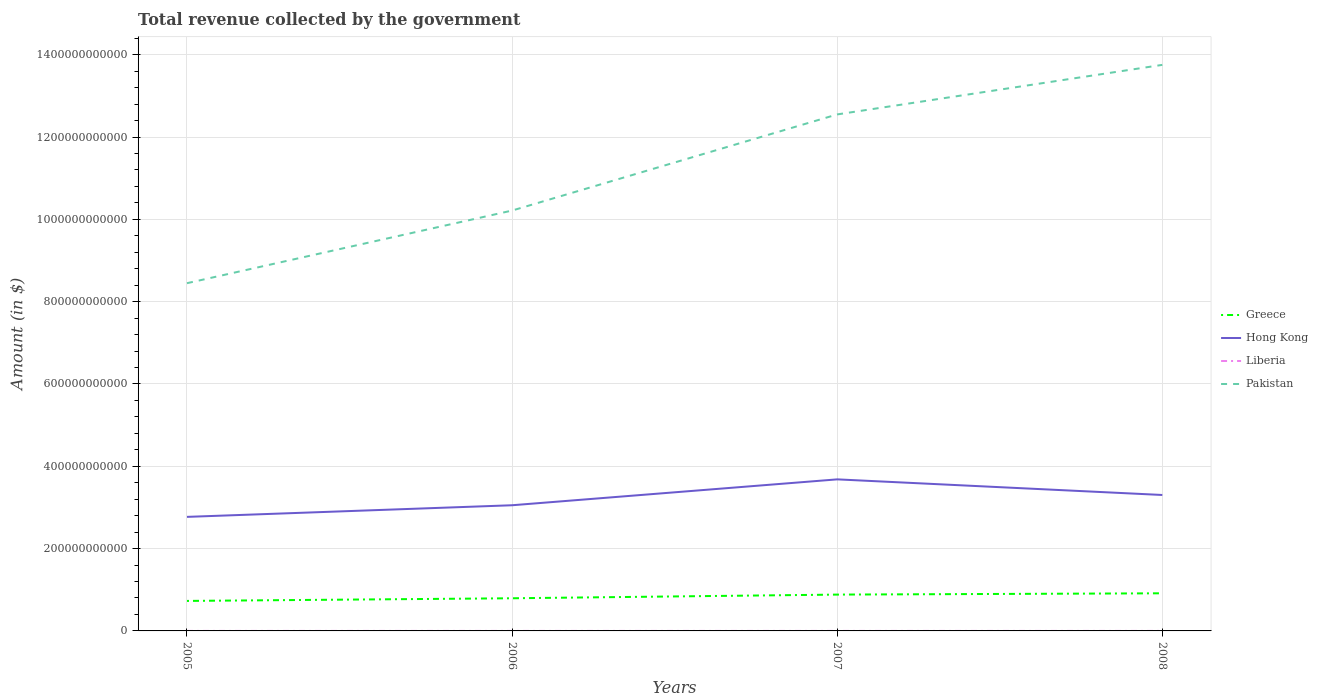Does the line corresponding to Pakistan intersect with the line corresponding to Hong Kong?
Your answer should be very brief. No. Is the number of lines equal to the number of legend labels?
Your answer should be very brief. Yes. Across all years, what is the maximum total revenue collected by the government in Hong Kong?
Your answer should be compact. 2.77e+11. In which year was the total revenue collected by the government in Pakistan maximum?
Keep it short and to the point. 2005. What is the total total revenue collected by the government in Greece in the graph?
Give a very brief answer. -6.44e+09. What is the difference between the highest and the second highest total revenue collected by the government in Pakistan?
Make the answer very short. 5.30e+11. What is the difference between two consecutive major ticks on the Y-axis?
Make the answer very short. 2.00e+11. Are the values on the major ticks of Y-axis written in scientific E-notation?
Provide a succinct answer. No. Where does the legend appear in the graph?
Keep it short and to the point. Center right. How are the legend labels stacked?
Provide a succinct answer. Vertical. What is the title of the graph?
Your response must be concise. Total revenue collected by the government. What is the label or title of the X-axis?
Keep it short and to the point. Years. What is the label or title of the Y-axis?
Your answer should be compact. Amount (in $). What is the Amount (in $) of Greece in 2005?
Provide a short and direct response. 7.29e+1. What is the Amount (in $) in Hong Kong in 2005?
Ensure brevity in your answer.  2.77e+11. What is the Amount (in $) in Liberia in 2005?
Provide a succinct answer. 1.39e+06. What is the Amount (in $) in Pakistan in 2005?
Make the answer very short. 8.45e+11. What is the Amount (in $) in Greece in 2006?
Make the answer very short. 7.93e+1. What is the Amount (in $) in Hong Kong in 2006?
Your response must be concise. 3.05e+11. What is the Amount (in $) of Liberia in 2006?
Keep it short and to the point. 1.46e+06. What is the Amount (in $) in Pakistan in 2006?
Give a very brief answer. 1.02e+12. What is the Amount (in $) in Greece in 2007?
Offer a terse response. 8.83e+1. What is the Amount (in $) in Hong Kong in 2007?
Keep it short and to the point. 3.68e+11. What is the Amount (in $) in Liberia in 2007?
Keep it short and to the point. 2.40e+06. What is the Amount (in $) of Pakistan in 2007?
Your answer should be compact. 1.25e+12. What is the Amount (in $) of Greece in 2008?
Your answer should be very brief. 9.14e+1. What is the Amount (in $) of Hong Kong in 2008?
Keep it short and to the point. 3.30e+11. What is the Amount (in $) in Liberia in 2008?
Provide a succinct answer. 3.18e+06. What is the Amount (in $) of Pakistan in 2008?
Make the answer very short. 1.38e+12. Across all years, what is the maximum Amount (in $) in Greece?
Make the answer very short. 9.14e+1. Across all years, what is the maximum Amount (in $) in Hong Kong?
Offer a very short reply. 3.68e+11. Across all years, what is the maximum Amount (in $) in Liberia?
Provide a succinct answer. 3.18e+06. Across all years, what is the maximum Amount (in $) of Pakistan?
Offer a very short reply. 1.38e+12. Across all years, what is the minimum Amount (in $) in Greece?
Provide a succinct answer. 7.29e+1. Across all years, what is the minimum Amount (in $) of Hong Kong?
Provide a succinct answer. 2.77e+11. Across all years, what is the minimum Amount (in $) of Liberia?
Ensure brevity in your answer.  1.39e+06. Across all years, what is the minimum Amount (in $) of Pakistan?
Ensure brevity in your answer.  8.45e+11. What is the total Amount (in $) of Greece in the graph?
Offer a terse response. 3.32e+11. What is the total Amount (in $) of Hong Kong in the graph?
Provide a short and direct response. 1.28e+12. What is the total Amount (in $) in Liberia in the graph?
Give a very brief answer. 8.43e+06. What is the total Amount (in $) of Pakistan in the graph?
Provide a succinct answer. 4.50e+12. What is the difference between the Amount (in $) of Greece in 2005 and that in 2006?
Keep it short and to the point. -6.44e+09. What is the difference between the Amount (in $) of Hong Kong in 2005 and that in 2006?
Your answer should be very brief. -2.82e+1. What is the difference between the Amount (in $) of Liberia in 2005 and that in 2006?
Offer a very short reply. -6.64e+04. What is the difference between the Amount (in $) of Pakistan in 2005 and that in 2006?
Make the answer very short. -1.77e+11. What is the difference between the Amount (in $) in Greece in 2005 and that in 2007?
Offer a very short reply. -1.54e+1. What is the difference between the Amount (in $) of Hong Kong in 2005 and that in 2007?
Your answer should be compact. -9.11e+1. What is the difference between the Amount (in $) in Liberia in 2005 and that in 2007?
Offer a terse response. -1.01e+06. What is the difference between the Amount (in $) of Pakistan in 2005 and that in 2007?
Your response must be concise. -4.10e+11. What is the difference between the Amount (in $) of Greece in 2005 and that in 2008?
Make the answer very short. -1.85e+1. What is the difference between the Amount (in $) of Hong Kong in 2005 and that in 2008?
Provide a short and direct response. -5.32e+1. What is the difference between the Amount (in $) in Liberia in 2005 and that in 2008?
Ensure brevity in your answer.  -1.79e+06. What is the difference between the Amount (in $) in Pakistan in 2005 and that in 2008?
Ensure brevity in your answer.  -5.30e+11. What is the difference between the Amount (in $) of Greece in 2006 and that in 2007?
Provide a succinct answer. -8.93e+09. What is the difference between the Amount (in $) in Hong Kong in 2006 and that in 2007?
Make the answer very short. -6.29e+1. What is the difference between the Amount (in $) of Liberia in 2006 and that in 2007?
Your answer should be compact. -9.40e+05. What is the difference between the Amount (in $) of Pakistan in 2006 and that in 2007?
Provide a succinct answer. -2.34e+11. What is the difference between the Amount (in $) in Greece in 2006 and that in 2008?
Your answer should be very brief. -1.21e+1. What is the difference between the Amount (in $) of Hong Kong in 2006 and that in 2008?
Make the answer very short. -2.49e+1. What is the difference between the Amount (in $) of Liberia in 2006 and that in 2008?
Make the answer very short. -1.73e+06. What is the difference between the Amount (in $) in Pakistan in 2006 and that in 2008?
Your answer should be compact. -3.54e+11. What is the difference between the Amount (in $) in Greece in 2007 and that in 2008?
Offer a very short reply. -3.15e+09. What is the difference between the Amount (in $) of Hong Kong in 2007 and that in 2008?
Ensure brevity in your answer.  3.80e+1. What is the difference between the Amount (in $) of Liberia in 2007 and that in 2008?
Offer a very short reply. -7.87e+05. What is the difference between the Amount (in $) in Pakistan in 2007 and that in 2008?
Give a very brief answer. -1.20e+11. What is the difference between the Amount (in $) in Greece in 2005 and the Amount (in $) in Hong Kong in 2006?
Your response must be concise. -2.32e+11. What is the difference between the Amount (in $) in Greece in 2005 and the Amount (in $) in Liberia in 2006?
Your response must be concise. 7.29e+1. What is the difference between the Amount (in $) of Greece in 2005 and the Amount (in $) of Pakistan in 2006?
Your response must be concise. -9.49e+11. What is the difference between the Amount (in $) of Hong Kong in 2005 and the Amount (in $) of Liberia in 2006?
Your response must be concise. 2.77e+11. What is the difference between the Amount (in $) in Hong Kong in 2005 and the Amount (in $) in Pakistan in 2006?
Provide a short and direct response. -7.44e+11. What is the difference between the Amount (in $) in Liberia in 2005 and the Amount (in $) in Pakistan in 2006?
Give a very brief answer. -1.02e+12. What is the difference between the Amount (in $) of Greece in 2005 and the Amount (in $) of Hong Kong in 2007?
Your response must be concise. -2.95e+11. What is the difference between the Amount (in $) in Greece in 2005 and the Amount (in $) in Liberia in 2007?
Provide a succinct answer. 7.29e+1. What is the difference between the Amount (in $) in Greece in 2005 and the Amount (in $) in Pakistan in 2007?
Give a very brief answer. -1.18e+12. What is the difference between the Amount (in $) of Hong Kong in 2005 and the Amount (in $) of Liberia in 2007?
Ensure brevity in your answer.  2.77e+11. What is the difference between the Amount (in $) of Hong Kong in 2005 and the Amount (in $) of Pakistan in 2007?
Your answer should be compact. -9.78e+11. What is the difference between the Amount (in $) in Liberia in 2005 and the Amount (in $) in Pakistan in 2007?
Make the answer very short. -1.25e+12. What is the difference between the Amount (in $) of Greece in 2005 and the Amount (in $) of Hong Kong in 2008?
Your answer should be compact. -2.57e+11. What is the difference between the Amount (in $) in Greece in 2005 and the Amount (in $) in Liberia in 2008?
Provide a succinct answer. 7.29e+1. What is the difference between the Amount (in $) in Greece in 2005 and the Amount (in $) in Pakistan in 2008?
Your answer should be compact. -1.30e+12. What is the difference between the Amount (in $) in Hong Kong in 2005 and the Amount (in $) in Liberia in 2008?
Your answer should be compact. 2.77e+11. What is the difference between the Amount (in $) of Hong Kong in 2005 and the Amount (in $) of Pakistan in 2008?
Offer a very short reply. -1.10e+12. What is the difference between the Amount (in $) of Liberia in 2005 and the Amount (in $) of Pakistan in 2008?
Ensure brevity in your answer.  -1.38e+12. What is the difference between the Amount (in $) in Greece in 2006 and the Amount (in $) in Hong Kong in 2007?
Provide a succinct answer. -2.89e+11. What is the difference between the Amount (in $) in Greece in 2006 and the Amount (in $) in Liberia in 2007?
Offer a very short reply. 7.93e+1. What is the difference between the Amount (in $) in Greece in 2006 and the Amount (in $) in Pakistan in 2007?
Your answer should be compact. -1.18e+12. What is the difference between the Amount (in $) of Hong Kong in 2006 and the Amount (in $) of Liberia in 2007?
Your answer should be compact. 3.05e+11. What is the difference between the Amount (in $) in Hong Kong in 2006 and the Amount (in $) in Pakistan in 2007?
Provide a succinct answer. -9.50e+11. What is the difference between the Amount (in $) of Liberia in 2006 and the Amount (in $) of Pakistan in 2007?
Your response must be concise. -1.25e+12. What is the difference between the Amount (in $) of Greece in 2006 and the Amount (in $) of Hong Kong in 2008?
Your answer should be compact. -2.51e+11. What is the difference between the Amount (in $) in Greece in 2006 and the Amount (in $) in Liberia in 2008?
Offer a terse response. 7.93e+1. What is the difference between the Amount (in $) in Greece in 2006 and the Amount (in $) in Pakistan in 2008?
Provide a succinct answer. -1.30e+12. What is the difference between the Amount (in $) of Hong Kong in 2006 and the Amount (in $) of Liberia in 2008?
Offer a very short reply. 3.05e+11. What is the difference between the Amount (in $) in Hong Kong in 2006 and the Amount (in $) in Pakistan in 2008?
Your answer should be very brief. -1.07e+12. What is the difference between the Amount (in $) of Liberia in 2006 and the Amount (in $) of Pakistan in 2008?
Your response must be concise. -1.38e+12. What is the difference between the Amount (in $) of Greece in 2007 and the Amount (in $) of Hong Kong in 2008?
Ensure brevity in your answer.  -2.42e+11. What is the difference between the Amount (in $) of Greece in 2007 and the Amount (in $) of Liberia in 2008?
Your answer should be very brief. 8.83e+1. What is the difference between the Amount (in $) of Greece in 2007 and the Amount (in $) of Pakistan in 2008?
Your answer should be very brief. -1.29e+12. What is the difference between the Amount (in $) of Hong Kong in 2007 and the Amount (in $) of Liberia in 2008?
Offer a terse response. 3.68e+11. What is the difference between the Amount (in $) in Hong Kong in 2007 and the Amount (in $) in Pakistan in 2008?
Your answer should be compact. -1.01e+12. What is the difference between the Amount (in $) of Liberia in 2007 and the Amount (in $) of Pakistan in 2008?
Provide a succinct answer. -1.38e+12. What is the average Amount (in $) in Greece per year?
Keep it short and to the point. 8.30e+1. What is the average Amount (in $) of Hong Kong per year?
Give a very brief answer. 3.20e+11. What is the average Amount (in $) in Liberia per year?
Ensure brevity in your answer.  2.11e+06. What is the average Amount (in $) in Pakistan per year?
Keep it short and to the point. 1.12e+12. In the year 2005, what is the difference between the Amount (in $) of Greece and Amount (in $) of Hong Kong?
Make the answer very short. -2.04e+11. In the year 2005, what is the difference between the Amount (in $) of Greece and Amount (in $) of Liberia?
Make the answer very short. 7.29e+1. In the year 2005, what is the difference between the Amount (in $) in Greece and Amount (in $) in Pakistan?
Offer a terse response. -7.72e+11. In the year 2005, what is the difference between the Amount (in $) of Hong Kong and Amount (in $) of Liberia?
Offer a terse response. 2.77e+11. In the year 2005, what is the difference between the Amount (in $) in Hong Kong and Amount (in $) in Pakistan?
Your answer should be compact. -5.68e+11. In the year 2005, what is the difference between the Amount (in $) in Liberia and Amount (in $) in Pakistan?
Make the answer very short. -8.45e+11. In the year 2006, what is the difference between the Amount (in $) of Greece and Amount (in $) of Hong Kong?
Make the answer very short. -2.26e+11. In the year 2006, what is the difference between the Amount (in $) of Greece and Amount (in $) of Liberia?
Provide a short and direct response. 7.93e+1. In the year 2006, what is the difference between the Amount (in $) in Greece and Amount (in $) in Pakistan?
Provide a short and direct response. -9.42e+11. In the year 2006, what is the difference between the Amount (in $) in Hong Kong and Amount (in $) in Liberia?
Make the answer very short. 3.05e+11. In the year 2006, what is the difference between the Amount (in $) of Hong Kong and Amount (in $) of Pakistan?
Provide a short and direct response. -7.16e+11. In the year 2006, what is the difference between the Amount (in $) of Liberia and Amount (in $) of Pakistan?
Ensure brevity in your answer.  -1.02e+12. In the year 2007, what is the difference between the Amount (in $) in Greece and Amount (in $) in Hong Kong?
Offer a terse response. -2.80e+11. In the year 2007, what is the difference between the Amount (in $) of Greece and Amount (in $) of Liberia?
Make the answer very short. 8.83e+1. In the year 2007, what is the difference between the Amount (in $) in Greece and Amount (in $) in Pakistan?
Offer a very short reply. -1.17e+12. In the year 2007, what is the difference between the Amount (in $) in Hong Kong and Amount (in $) in Liberia?
Ensure brevity in your answer.  3.68e+11. In the year 2007, what is the difference between the Amount (in $) in Hong Kong and Amount (in $) in Pakistan?
Provide a short and direct response. -8.87e+11. In the year 2007, what is the difference between the Amount (in $) in Liberia and Amount (in $) in Pakistan?
Make the answer very short. -1.25e+12. In the year 2008, what is the difference between the Amount (in $) in Greece and Amount (in $) in Hong Kong?
Provide a succinct answer. -2.39e+11. In the year 2008, what is the difference between the Amount (in $) in Greece and Amount (in $) in Liberia?
Keep it short and to the point. 9.14e+1. In the year 2008, what is the difference between the Amount (in $) in Greece and Amount (in $) in Pakistan?
Offer a very short reply. -1.28e+12. In the year 2008, what is the difference between the Amount (in $) of Hong Kong and Amount (in $) of Liberia?
Provide a short and direct response. 3.30e+11. In the year 2008, what is the difference between the Amount (in $) of Hong Kong and Amount (in $) of Pakistan?
Offer a terse response. -1.05e+12. In the year 2008, what is the difference between the Amount (in $) of Liberia and Amount (in $) of Pakistan?
Provide a succinct answer. -1.38e+12. What is the ratio of the Amount (in $) in Greece in 2005 to that in 2006?
Give a very brief answer. 0.92. What is the ratio of the Amount (in $) of Hong Kong in 2005 to that in 2006?
Keep it short and to the point. 0.91. What is the ratio of the Amount (in $) of Liberia in 2005 to that in 2006?
Offer a very short reply. 0.95. What is the ratio of the Amount (in $) in Pakistan in 2005 to that in 2006?
Ensure brevity in your answer.  0.83. What is the ratio of the Amount (in $) in Greece in 2005 to that in 2007?
Give a very brief answer. 0.83. What is the ratio of the Amount (in $) of Hong Kong in 2005 to that in 2007?
Give a very brief answer. 0.75. What is the ratio of the Amount (in $) in Liberia in 2005 to that in 2007?
Provide a succinct answer. 0.58. What is the ratio of the Amount (in $) in Pakistan in 2005 to that in 2007?
Your response must be concise. 0.67. What is the ratio of the Amount (in $) in Greece in 2005 to that in 2008?
Your answer should be very brief. 0.8. What is the ratio of the Amount (in $) in Hong Kong in 2005 to that in 2008?
Offer a terse response. 0.84. What is the ratio of the Amount (in $) in Liberia in 2005 to that in 2008?
Provide a succinct answer. 0.44. What is the ratio of the Amount (in $) in Pakistan in 2005 to that in 2008?
Your response must be concise. 0.61. What is the ratio of the Amount (in $) in Greece in 2006 to that in 2007?
Offer a very short reply. 0.9. What is the ratio of the Amount (in $) in Hong Kong in 2006 to that in 2007?
Offer a terse response. 0.83. What is the ratio of the Amount (in $) in Liberia in 2006 to that in 2007?
Your answer should be very brief. 0.61. What is the ratio of the Amount (in $) in Pakistan in 2006 to that in 2007?
Keep it short and to the point. 0.81. What is the ratio of the Amount (in $) in Greece in 2006 to that in 2008?
Keep it short and to the point. 0.87. What is the ratio of the Amount (in $) in Hong Kong in 2006 to that in 2008?
Give a very brief answer. 0.92. What is the ratio of the Amount (in $) in Liberia in 2006 to that in 2008?
Ensure brevity in your answer.  0.46. What is the ratio of the Amount (in $) of Pakistan in 2006 to that in 2008?
Offer a very short reply. 0.74. What is the ratio of the Amount (in $) in Greece in 2007 to that in 2008?
Provide a short and direct response. 0.97. What is the ratio of the Amount (in $) of Hong Kong in 2007 to that in 2008?
Keep it short and to the point. 1.11. What is the ratio of the Amount (in $) of Liberia in 2007 to that in 2008?
Give a very brief answer. 0.75. What is the ratio of the Amount (in $) of Pakistan in 2007 to that in 2008?
Give a very brief answer. 0.91. What is the difference between the highest and the second highest Amount (in $) of Greece?
Offer a very short reply. 3.15e+09. What is the difference between the highest and the second highest Amount (in $) of Hong Kong?
Your response must be concise. 3.80e+1. What is the difference between the highest and the second highest Amount (in $) in Liberia?
Offer a terse response. 7.87e+05. What is the difference between the highest and the second highest Amount (in $) in Pakistan?
Provide a short and direct response. 1.20e+11. What is the difference between the highest and the lowest Amount (in $) of Greece?
Ensure brevity in your answer.  1.85e+1. What is the difference between the highest and the lowest Amount (in $) of Hong Kong?
Keep it short and to the point. 9.11e+1. What is the difference between the highest and the lowest Amount (in $) of Liberia?
Your answer should be very brief. 1.79e+06. What is the difference between the highest and the lowest Amount (in $) of Pakistan?
Give a very brief answer. 5.30e+11. 